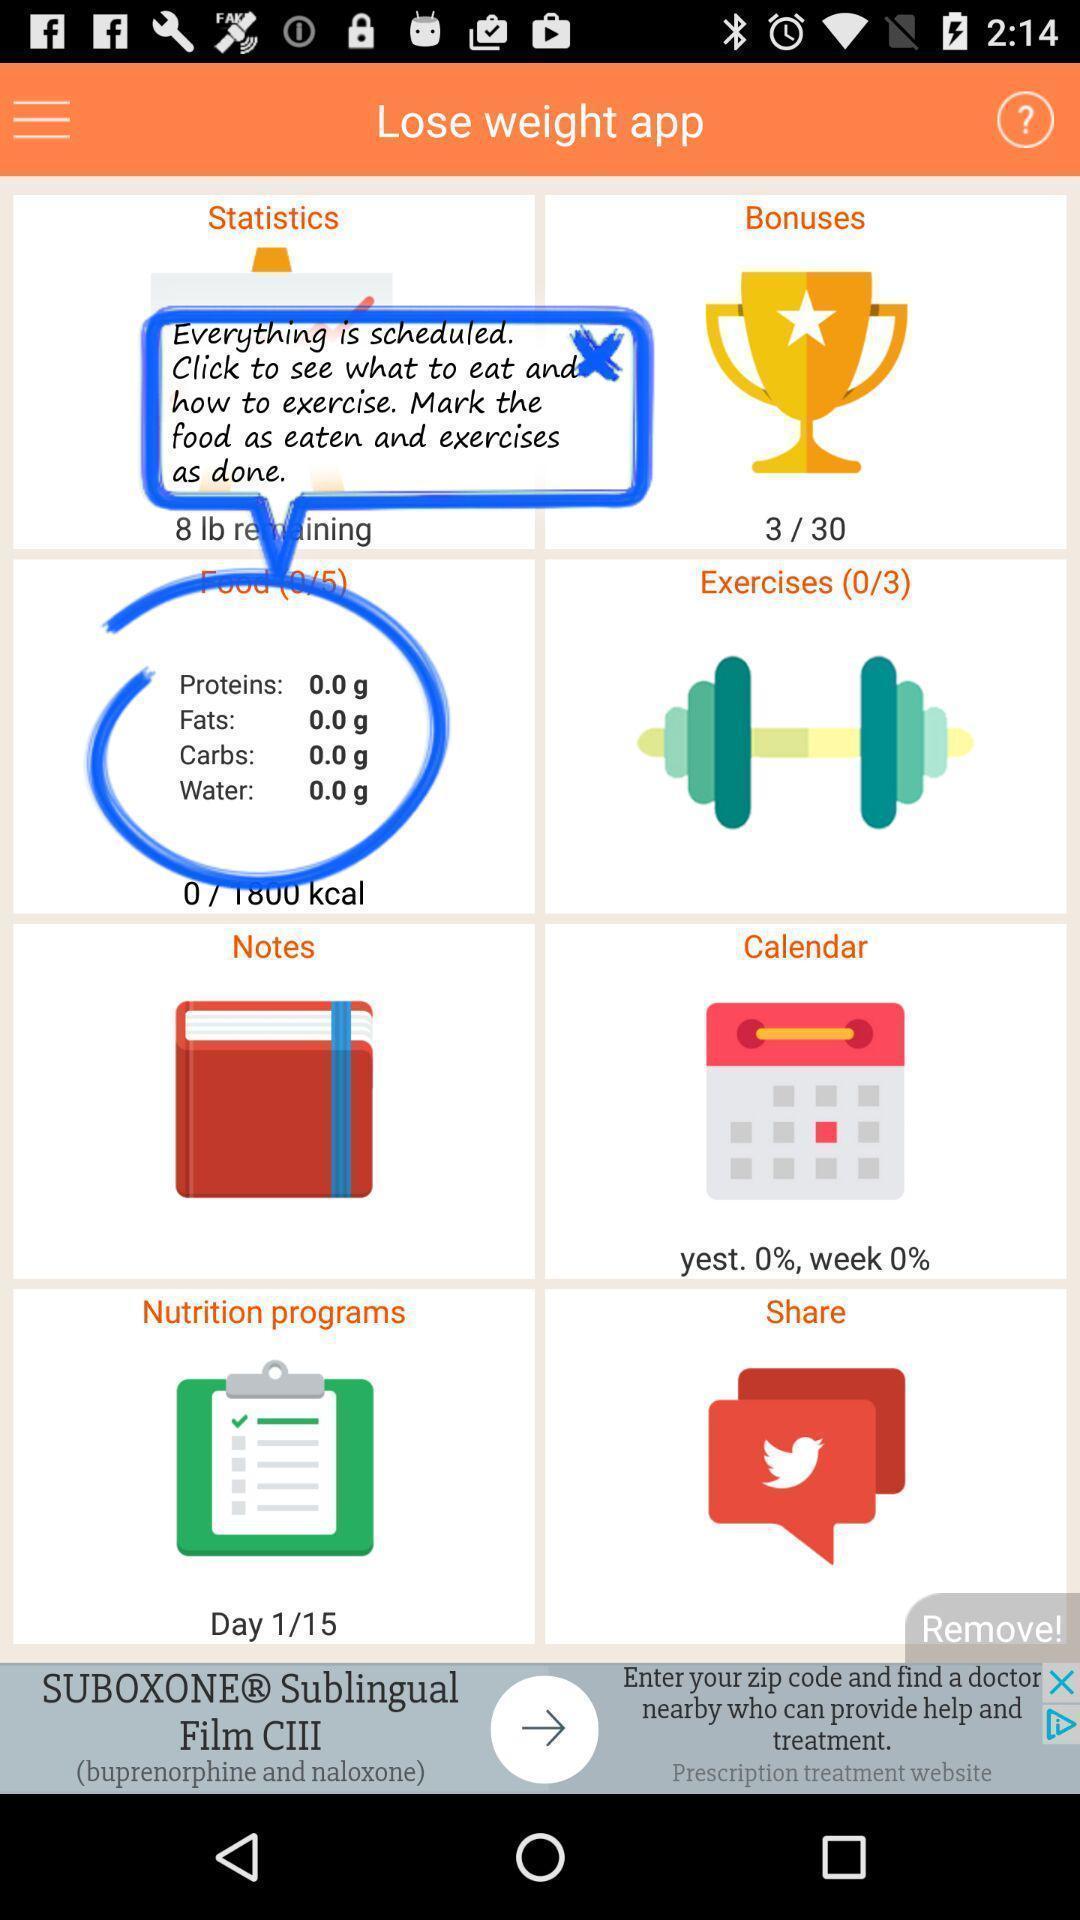What details can you identify in this image? Screen showing page with options. 